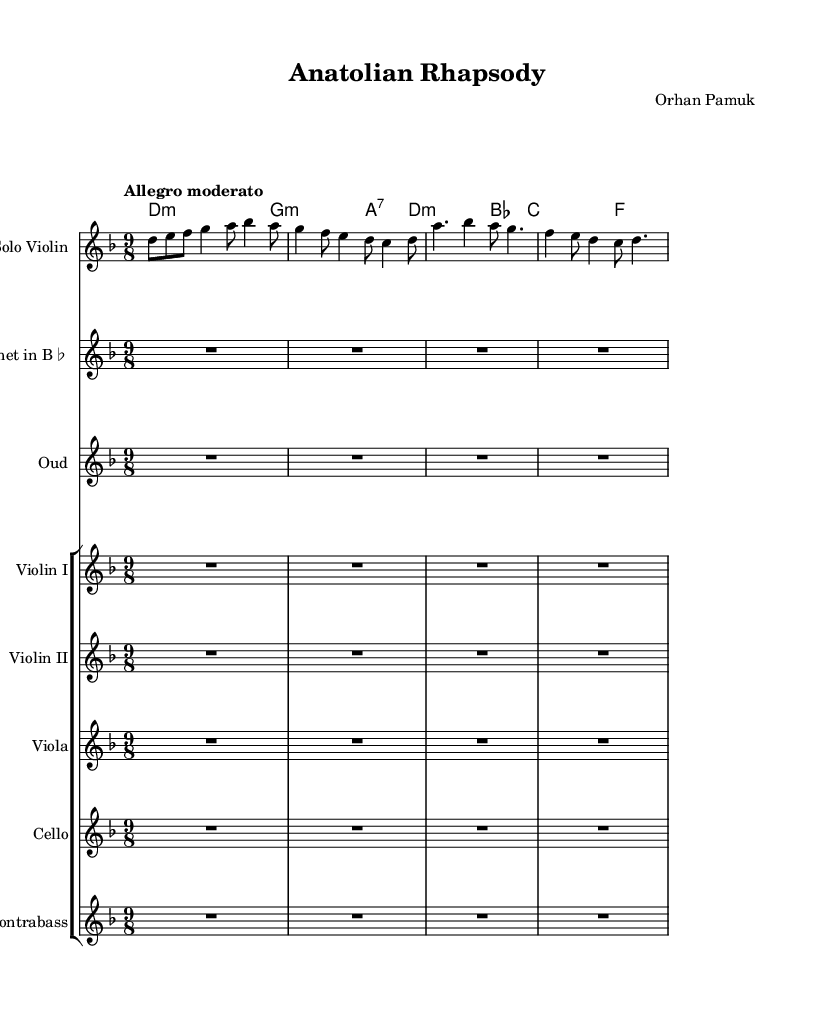What is the key signature of this piece? The key signature is D minor, which is indicated by one flat (B♭) in the key signature area at the beginning of the score.
Answer: D minor What is the time signature of the composition? The time signature is 9/8, which is shown at the beginning of the score, indicating that there are nine eighth-note beats in each measure.
Answer: 9/8 What is the tempo marking for this music? The tempo marking is "Allegro moderato," which is located at the start of the score and indicates a moderately quick tempo.
Answer: Allegro moderato How many instruments are present in the score? The score features a total of six instruments: Solo Violin, Clarinet in B♭, Oud, Violin I, Violin II, Viola, Cello, and Contrabass. This can be counted from the different staves in the score.
Answer: Eight What instruments are indicated to have rests for the entire duration? The Clarinet in B♭ and Oud both have rests indicated for the entire measure, represented by "R1*9/8*4" in their parts.
Answer: Clarinet and Oud Which chord is the first one listed in the chord section? The first chord listed is D minor, denoted as "d1:m" in the chord names. It appears at the beginning of the chord section.
Answer: D minor 